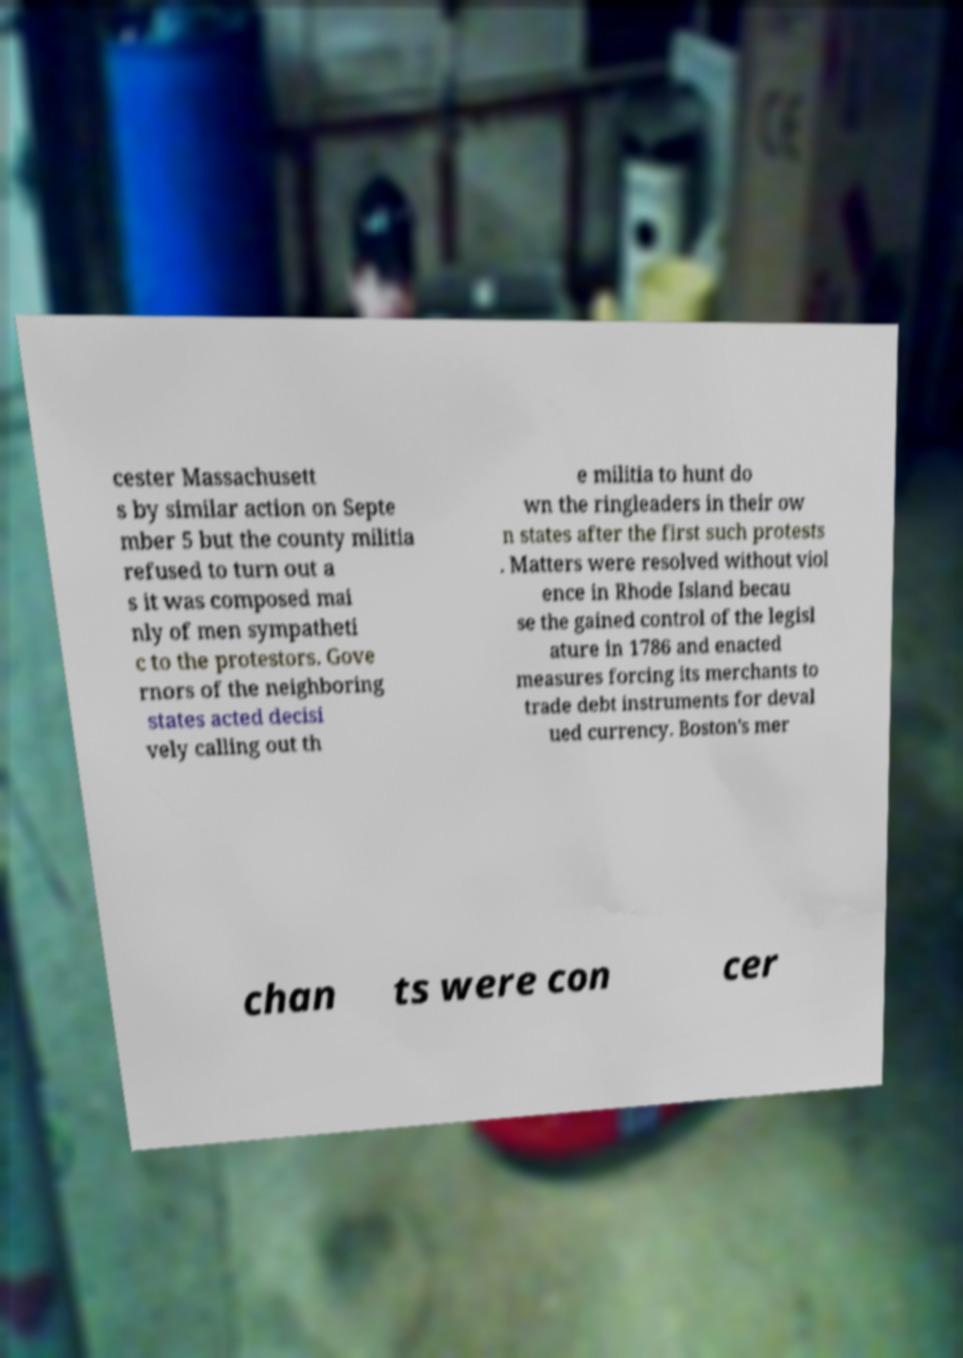Please read and relay the text visible in this image. What does it say? cester Massachusett s by similar action on Septe mber 5 but the county militia refused to turn out a s it was composed mai nly of men sympatheti c to the protestors. Gove rnors of the neighboring states acted decisi vely calling out th e militia to hunt do wn the ringleaders in their ow n states after the first such protests . Matters were resolved without viol ence in Rhode Island becau se the gained control of the legisl ature in 1786 and enacted measures forcing its merchants to trade debt instruments for deval ued currency. Boston's mer chan ts were con cer 